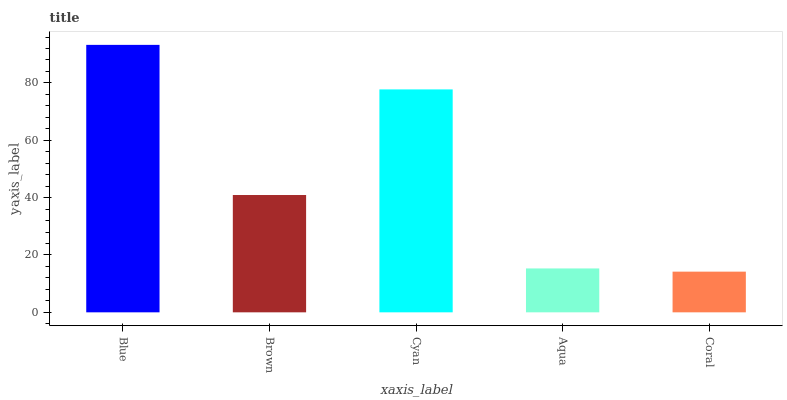Is Brown the minimum?
Answer yes or no. No. Is Brown the maximum?
Answer yes or no. No. Is Blue greater than Brown?
Answer yes or no. Yes. Is Brown less than Blue?
Answer yes or no. Yes. Is Brown greater than Blue?
Answer yes or no. No. Is Blue less than Brown?
Answer yes or no. No. Is Brown the high median?
Answer yes or no. Yes. Is Brown the low median?
Answer yes or no. Yes. Is Coral the high median?
Answer yes or no. No. Is Aqua the low median?
Answer yes or no. No. 